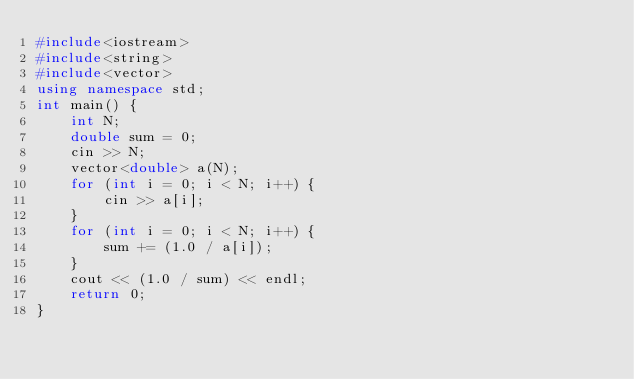<code> <loc_0><loc_0><loc_500><loc_500><_C++_>#include<iostream>
#include<string>
#include<vector>
using namespace std;
int main() {
	int N;
	double sum = 0;
	cin >> N;
	vector<double> a(N);
	for (int i = 0; i < N; i++) {
		cin >> a[i];
	}
	for (int i = 0; i < N; i++) {
		sum += (1.0 / a[i]);
	}
	cout << (1.0 / sum) << endl;
	return 0;
}</code> 